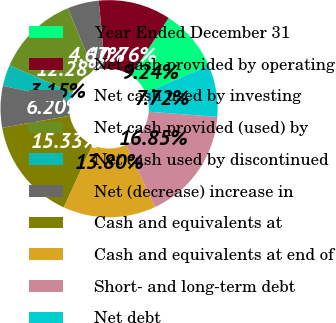Convert chart to OTSL. <chart><loc_0><loc_0><loc_500><loc_500><pie_chart><fcel>Year Ended December 31<fcel>Net cash provided by operating<fcel>Net cash used by investing<fcel>Net cash provided (used) by<fcel>Net cash used by discontinued<fcel>Net (decrease) increase in<fcel>Cash and equivalents at<fcel>Cash and equivalents at end of<fcel>Short- and long-term debt<fcel>Net debt<nl><fcel>9.24%<fcel>10.76%<fcel>4.67%<fcel>12.28%<fcel>3.15%<fcel>6.2%<fcel>15.33%<fcel>13.8%<fcel>16.85%<fcel>7.72%<nl></chart> 